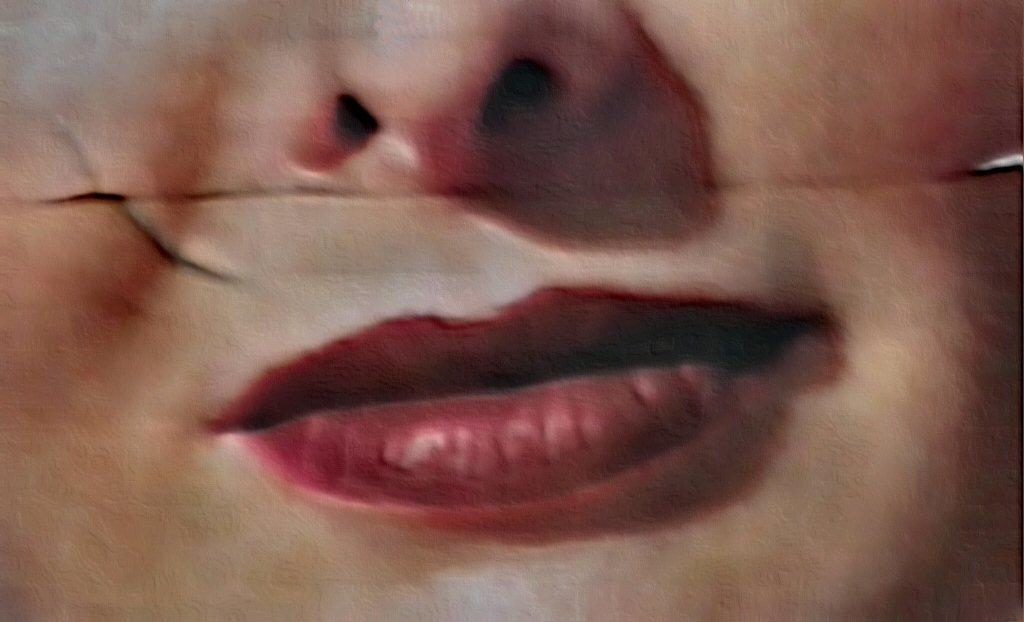What is the main subject of the image? The image contains a human face. What specific facial features can be seen in the image? The nose and lips are visible in the image. How would you describe the clarity of the image? The image is partially blurred. What type of cave can be seen in the background of the image? There is no cave present in the image; it features a human face with visible facial features. 